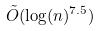<formula> <loc_0><loc_0><loc_500><loc_500>\tilde { O } ( \log ( n ) ^ { 7 . 5 } )</formula> 